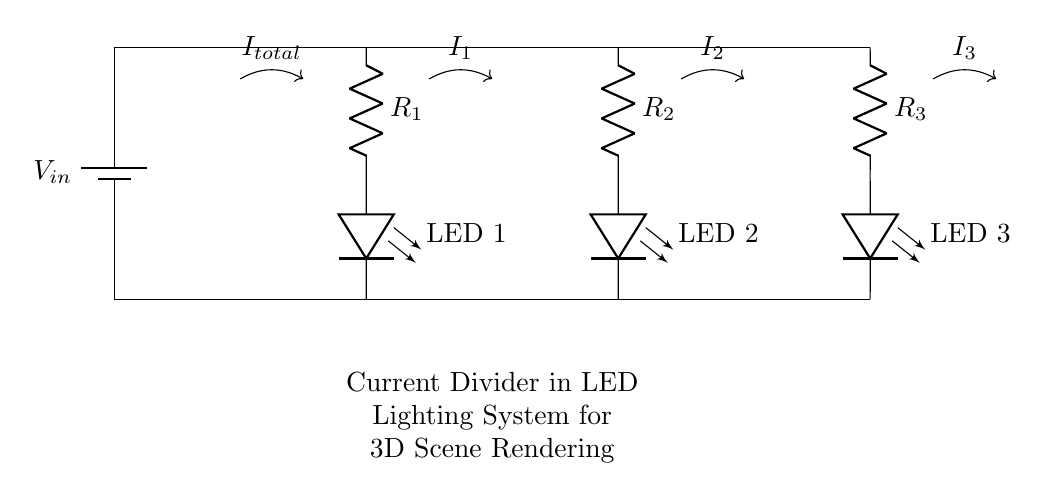What is the total current entering the circuit? The total current \( I_{total} \) is represented by the arrow labeled \( I_{total} \) in the diagram, showing the incoming current before flowing through the resistors and LEDs.
Answer: I total What components are included in the current divider circuit? The circuit includes a battery, three resistors (R1, R2, R3), and three LEDs (LED 1, LED 2, LED 3), which can be identified by their respective symbols in the diagram.
Answer: Battery, R1, R2, R3, LED 1, LED 2, LED 3 How many branches are there in this circuit? The current divider creates three distinct branches, each containing one resistor and one LED, leading to R1 and LED 1, R2 and LED 2, and R3 and LED 3.
Answer: Three What determines the current through the LEDs in this circuit? The current through each LED is determined by the resistance values of R1, R2, and R3, which divides the total current proportionally based on their relative values.
Answer: Resistance values If R1 is halved, how will the current through LED 1 change? Halving R1 will increase the current through LED 1 because less resistance allows more current to flow, following the current divider rule. Therefore, the current through LED 1 will increase.
Answer: Increase What is the function of R2 in the current divider? R2 functions to limit the current flowing through LED 2, ensuring that it operates within safe limits and shares the total current with the other branches based on resistance values.
Answer: Limit current What happens to LED 3 if its resistance, R3, is increased significantly? If R3 is increased significantly, the current through LED 3 will decrease, as the higher resistance will restrict the flow of current compared to the other branches, following the current divider principle.
Answer: Decrease 